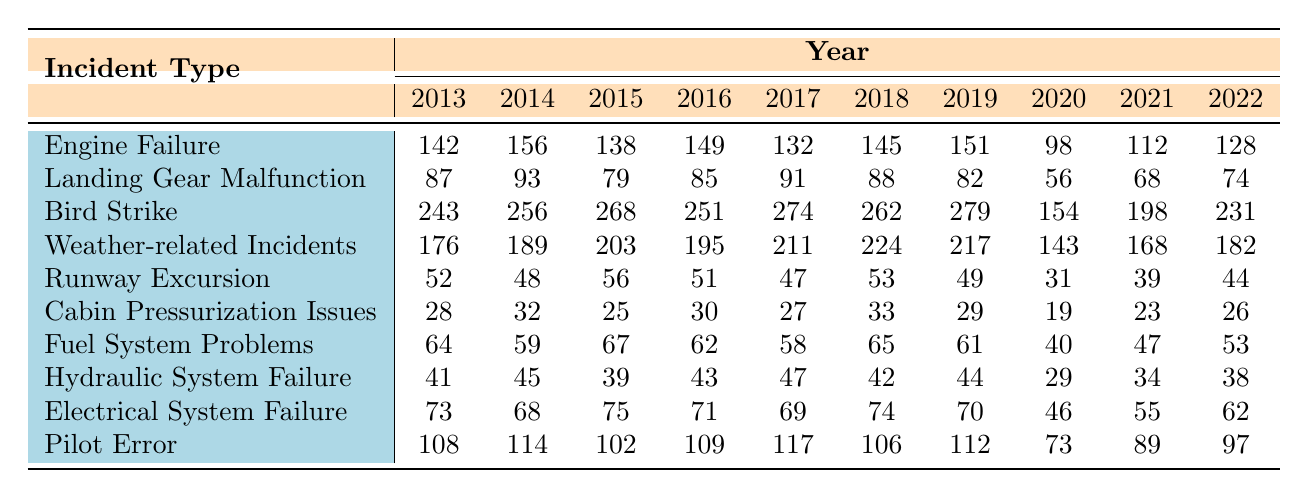What was the incident type with the highest number of reports in 2019? In 2019, the total reports for each incident type are: Engine Failure (151), Landing Gear Malfunction (82), Bird Strike (279), Weather-related Incidents (217), Runway Excursion (49), Cabin Pressurization Issues (29), Fuel System Problems (61), Hydraulic System Failure (44), Electrical System Failure (70), and Pilot Error (112). The highest is Bird Strike with 279 reports.
Answer: Bird Strike What was the average number of incidents for Electrical System Failure over the last decade? To find the average for Electrical System Failure, sum the annual reports: (73 + 68 + 75 + 71 + 69 + 74 + 70 + 46 + 55 + 62) = 693. Then divide by the number of years (10): 693/10 = 69.3.
Answer: 69.3 How many incidents were reported for Runway Excursion in 2016? The table lists Runway Excursion as having 51 incidents in 2016.
Answer: 51 Did the incidents of Cabin Pressurization Issues increase from 2017 to 2018? In 2017, there were 27 incidents of Cabin Pressurization Issues, while in 2018, there were 33. Since 33 is greater than 27, this confirms an increase.
Answer: Yes What is the total number of incident reports for Bird Strike across all years? Summing the reports for Bird Strike: (243 + 256 + 268 + 251 + 274 + 262 + 279 + 154 + 198 + 231) = 2176.
Answer: 2176 Which incident type showed the greatest decrease in reports from 2018 to 2020? Calculating the decrease from 2018 to 2020 for each type: Engine Failure (145 to 98 = -47), Landing Gear Malfunction (88 to 56 = -32), Bird Strike (262 to 154 = -108), Weather-related Incidents (224 to 143 = -81), Runway Excursion (53 to 31 = -22), Cabin Pressurization Issues (33 to 19 = -14), Fuel System Problems (65 to 40 = -25), Hydraulic System Failure (42 to 29 = -13), Electrical System Failure (74 to 46 = -28), Pilot Error (106 to 73 = -33). The greatest decrease is Bird Strike with -108 incidents.
Answer: Bird Strike What was the trend in incidents of Engine Failure from 2013 to 2022? Observing the data: 2013 (142), 2014 (156), 2015 (138), 2016 (149), 2017 (132), 2018 (145), 2019 (151), 2020 (98), 2021 (112), and 2022 (128). The trend shows fluctuations with a peak in 2014, then a general decline starting in 2020.
Answer: Fluctuating decline Was the number of Bird Strikes greater than the total of Runway Excursion and Cabin Pressurization Issues combined in 2015? In 2015, Bird Strikes totaled 268, while Runway Excursion and Cabin Pressurization Issues combined had 56 and 25 respectively, (56 + 25 = 81). Since 268 is greater than 81, this is true.
Answer: Yes What was the highest number of incidents reported for Pilot Error in a single year? Looking through the yearly data for Pilot Error, the maximum value appears in 2017 with 117 incidents.
Answer: 117 In 2020, which incident type had the lowest number of reports? The reports for each type in 2020 are Engine Failure (98), Landing Gear Malfunction (56), Bird Strike (154), Weather-related Incidents (143), Runway Excursion (31), Cabin Pressurization Issues (19), Fuel System Problems (40), Hydraulic System Failure (29), Electrical System Failure (46), and Pilot Error (73). The lowest is Cabin Pressurization Issues at 19.
Answer: Cabin Pressurization Issues 